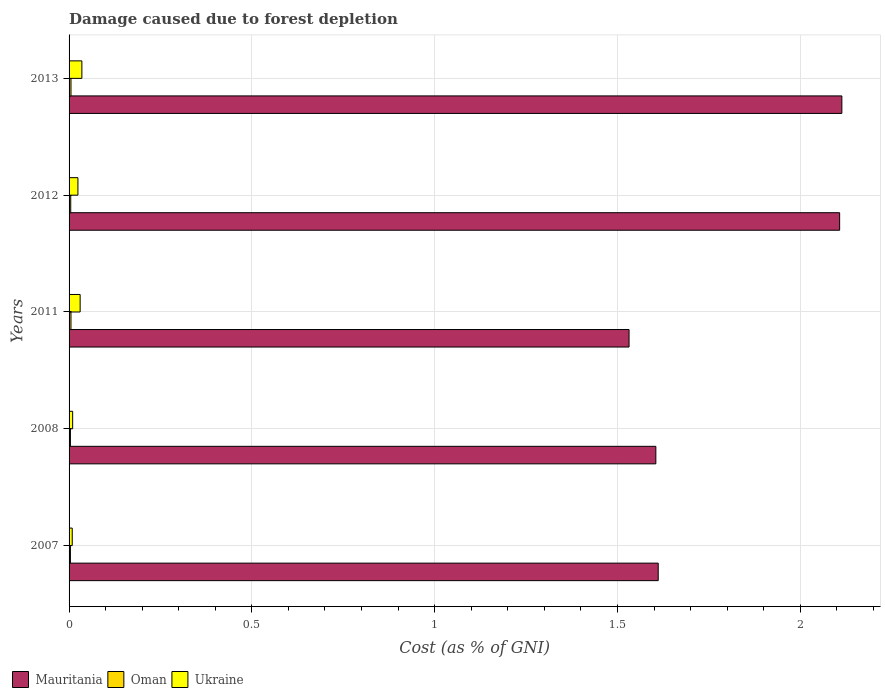Are the number of bars per tick equal to the number of legend labels?
Offer a very short reply. Yes. Are the number of bars on each tick of the Y-axis equal?
Provide a short and direct response. Yes. How many bars are there on the 3rd tick from the bottom?
Your answer should be compact. 3. What is the label of the 3rd group of bars from the top?
Offer a terse response. 2011. In how many cases, is the number of bars for a given year not equal to the number of legend labels?
Provide a succinct answer. 0. What is the cost of damage caused due to forest depletion in Ukraine in 2013?
Make the answer very short. 0.04. Across all years, what is the maximum cost of damage caused due to forest depletion in Ukraine?
Provide a short and direct response. 0.04. Across all years, what is the minimum cost of damage caused due to forest depletion in Mauritania?
Your answer should be compact. 1.53. In which year was the cost of damage caused due to forest depletion in Ukraine minimum?
Ensure brevity in your answer.  2007. What is the total cost of damage caused due to forest depletion in Mauritania in the graph?
Provide a succinct answer. 8.97. What is the difference between the cost of damage caused due to forest depletion in Oman in 2012 and that in 2013?
Make the answer very short. -0. What is the difference between the cost of damage caused due to forest depletion in Ukraine in 2008 and the cost of damage caused due to forest depletion in Mauritania in 2012?
Provide a short and direct response. -2.1. What is the average cost of damage caused due to forest depletion in Mauritania per year?
Your response must be concise. 1.79. In the year 2007, what is the difference between the cost of damage caused due to forest depletion in Mauritania and cost of damage caused due to forest depletion in Ukraine?
Your response must be concise. 1.6. In how many years, is the cost of damage caused due to forest depletion in Ukraine greater than 2 %?
Keep it short and to the point. 0. What is the ratio of the cost of damage caused due to forest depletion in Ukraine in 2007 to that in 2012?
Provide a succinct answer. 0.36. What is the difference between the highest and the second highest cost of damage caused due to forest depletion in Oman?
Provide a short and direct response. 2.9592775541019585e-5. What is the difference between the highest and the lowest cost of damage caused due to forest depletion in Mauritania?
Provide a short and direct response. 0.58. In how many years, is the cost of damage caused due to forest depletion in Ukraine greater than the average cost of damage caused due to forest depletion in Ukraine taken over all years?
Your response must be concise. 3. Is the sum of the cost of damage caused due to forest depletion in Ukraine in 2007 and 2008 greater than the maximum cost of damage caused due to forest depletion in Oman across all years?
Provide a succinct answer. Yes. What does the 2nd bar from the top in 2011 represents?
Keep it short and to the point. Oman. What does the 2nd bar from the bottom in 2011 represents?
Keep it short and to the point. Oman. Are all the bars in the graph horizontal?
Offer a very short reply. Yes. What is the difference between two consecutive major ticks on the X-axis?
Your answer should be compact. 0.5. Are the values on the major ticks of X-axis written in scientific E-notation?
Give a very brief answer. No. What is the title of the graph?
Make the answer very short. Damage caused due to forest depletion. Does "Israel" appear as one of the legend labels in the graph?
Keep it short and to the point. No. What is the label or title of the X-axis?
Provide a short and direct response. Cost (as % of GNI). What is the label or title of the Y-axis?
Provide a short and direct response. Years. What is the Cost (as % of GNI) in Mauritania in 2007?
Your answer should be compact. 1.61. What is the Cost (as % of GNI) of Oman in 2007?
Your response must be concise. 0. What is the Cost (as % of GNI) of Ukraine in 2007?
Give a very brief answer. 0.01. What is the Cost (as % of GNI) in Mauritania in 2008?
Give a very brief answer. 1.61. What is the Cost (as % of GNI) of Oman in 2008?
Keep it short and to the point. 0. What is the Cost (as % of GNI) of Ukraine in 2008?
Make the answer very short. 0.01. What is the Cost (as % of GNI) in Mauritania in 2011?
Your response must be concise. 1.53. What is the Cost (as % of GNI) of Oman in 2011?
Give a very brief answer. 0.01. What is the Cost (as % of GNI) of Ukraine in 2011?
Offer a very short reply. 0.03. What is the Cost (as % of GNI) of Mauritania in 2012?
Your response must be concise. 2.11. What is the Cost (as % of GNI) of Oman in 2012?
Your response must be concise. 0. What is the Cost (as % of GNI) in Ukraine in 2012?
Provide a succinct answer. 0.02. What is the Cost (as % of GNI) in Mauritania in 2013?
Your answer should be very brief. 2.11. What is the Cost (as % of GNI) in Oman in 2013?
Provide a short and direct response. 0.01. What is the Cost (as % of GNI) of Ukraine in 2013?
Make the answer very short. 0.04. Across all years, what is the maximum Cost (as % of GNI) in Mauritania?
Offer a terse response. 2.11. Across all years, what is the maximum Cost (as % of GNI) of Oman?
Make the answer very short. 0.01. Across all years, what is the maximum Cost (as % of GNI) of Ukraine?
Your answer should be compact. 0.04. Across all years, what is the minimum Cost (as % of GNI) of Mauritania?
Offer a very short reply. 1.53. Across all years, what is the minimum Cost (as % of GNI) in Oman?
Ensure brevity in your answer.  0. Across all years, what is the minimum Cost (as % of GNI) of Ukraine?
Make the answer very short. 0.01. What is the total Cost (as % of GNI) in Mauritania in the graph?
Your answer should be compact. 8.97. What is the total Cost (as % of GNI) of Oman in the graph?
Ensure brevity in your answer.  0.02. What is the total Cost (as % of GNI) of Ukraine in the graph?
Offer a very short reply. 0.11. What is the difference between the Cost (as % of GNI) of Mauritania in 2007 and that in 2008?
Provide a succinct answer. 0.01. What is the difference between the Cost (as % of GNI) in Ukraine in 2007 and that in 2008?
Your response must be concise. -0. What is the difference between the Cost (as % of GNI) of Mauritania in 2007 and that in 2011?
Ensure brevity in your answer.  0.08. What is the difference between the Cost (as % of GNI) in Oman in 2007 and that in 2011?
Make the answer very short. -0. What is the difference between the Cost (as % of GNI) in Ukraine in 2007 and that in 2011?
Offer a terse response. -0.02. What is the difference between the Cost (as % of GNI) in Mauritania in 2007 and that in 2012?
Ensure brevity in your answer.  -0.5. What is the difference between the Cost (as % of GNI) in Oman in 2007 and that in 2012?
Ensure brevity in your answer.  -0. What is the difference between the Cost (as % of GNI) in Ukraine in 2007 and that in 2012?
Ensure brevity in your answer.  -0.02. What is the difference between the Cost (as % of GNI) in Mauritania in 2007 and that in 2013?
Provide a short and direct response. -0.5. What is the difference between the Cost (as % of GNI) of Oman in 2007 and that in 2013?
Your answer should be compact. -0. What is the difference between the Cost (as % of GNI) in Ukraine in 2007 and that in 2013?
Make the answer very short. -0.03. What is the difference between the Cost (as % of GNI) in Mauritania in 2008 and that in 2011?
Your response must be concise. 0.07. What is the difference between the Cost (as % of GNI) of Oman in 2008 and that in 2011?
Make the answer very short. -0. What is the difference between the Cost (as % of GNI) of Ukraine in 2008 and that in 2011?
Offer a terse response. -0.02. What is the difference between the Cost (as % of GNI) in Mauritania in 2008 and that in 2012?
Provide a short and direct response. -0.5. What is the difference between the Cost (as % of GNI) of Oman in 2008 and that in 2012?
Ensure brevity in your answer.  -0. What is the difference between the Cost (as % of GNI) in Ukraine in 2008 and that in 2012?
Make the answer very short. -0.01. What is the difference between the Cost (as % of GNI) in Mauritania in 2008 and that in 2013?
Provide a short and direct response. -0.51. What is the difference between the Cost (as % of GNI) of Oman in 2008 and that in 2013?
Make the answer very short. -0. What is the difference between the Cost (as % of GNI) of Ukraine in 2008 and that in 2013?
Your answer should be compact. -0.03. What is the difference between the Cost (as % of GNI) in Mauritania in 2011 and that in 2012?
Provide a succinct answer. -0.58. What is the difference between the Cost (as % of GNI) of Oman in 2011 and that in 2012?
Make the answer very short. 0. What is the difference between the Cost (as % of GNI) of Ukraine in 2011 and that in 2012?
Your answer should be compact. 0.01. What is the difference between the Cost (as % of GNI) of Mauritania in 2011 and that in 2013?
Make the answer very short. -0.58. What is the difference between the Cost (as % of GNI) of Ukraine in 2011 and that in 2013?
Make the answer very short. -0. What is the difference between the Cost (as % of GNI) in Mauritania in 2012 and that in 2013?
Provide a succinct answer. -0.01. What is the difference between the Cost (as % of GNI) of Oman in 2012 and that in 2013?
Provide a short and direct response. -0. What is the difference between the Cost (as % of GNI) in Ukraine in 2012 and that in 2013?
Offer a terse response. -0.01. What is the difference between the Cost (as % of GNI) in Mauritania in 2007 and the Cost (as % of GNI) in Oman in 2008?
Provide a succinct answer. 1.61. What is the difference between the Cost (as % of GNI) in Mauritania in 2007 and the Cost (as % of GNI) in Ukraine in 2008?
Your answer should be compact. 1.6. What is the difference between the Cost (as % of GNI) in Oman in 2007 and the Cost (as % of GNI) in Ukraine in 2008?
Offer a very short reply. -0.01. What is the difference between the Cost (as % of GNI) of Mauritania in 2007 and the Cost (as % of GNI) of Oman in 2011?
Make the answer very short. 1.61. What is the difference between the Cost (as % of GNI) of Mauritania in 2007 and the Cost (as % of GNI) of Ukraine in 2011?
Your answer should be very brief. 1.58. What is the difference between the Cost (as % of GNI) of Oman in 2007 and the Cost (as % of GNI) of Ukraine in 2011?
Provide a short and direct response. -0.03. What is the difference between the Cost (as % of GNI) in Mauritania in 2007 and the Cost (as % of GNI) in Oman in 2012?
Give a very brief answer. 1.61. What is the difference between the Cost (as % of GNI) in Mauritania in 2007 and the Cost (as % of GNI) in Ukraine in 2012?
Give a very brief answer. 1.59. What is the difference between the Cost (as % of GNI) of Oman in 2007 and the Cost (as % of GNI) of Ukraine in 2012?
Make the answer very short. -0.02. What is the difference between the Cost (as % of GNI) of Mauritania in 2007 and the Cost (as % of GNI) of Oman in 2013?
Offer a very short reply. 1.61. What is the difference between the Cost (as % of GNI) in Mauritania in 2007 and the Cost (as % of GNI) in Ukraine in 2013?
Make the answer very short. 1.58. What is the difference between the Cost (as % of GNI) in Oman in 2007 and the Cost (as % of GNI) in Ukraine in 2013?
Your answer should be very brief. -0.03. What is the difference between the Cost (as % of GNI) in Mauritania in 2008 and the Cost (as % of GNI) in Oman in 2011?
Ensure brevity in your answer.  1.6. What is the difference between the Cost (as % of GNI) of Mauritania in 2008 and the Cost (as % of GNI) of Ukraine in 2011?
Offer a very short reply. 1.57. What is the difference between the Cost (as % of GNI) of Oman in 2008 and the Cost (as % of GNI) of Ukraine in 2011?
Provide a succinct answer. -0.03. What is the difference between the Cost (as % of GNI) in Mauritania in 2008 and the Cost (as % of GNI) in Oman in 2012?
Your response must be concise. 1.6. What is the difference between the Cost (as % of GNI) in Mauritania in 2008 and the Cost (as % of GNI) in Ukraine in 2012?
Ensure brevity in your answer.  1.58. What is the difference between the Cost (as % of GNI) of Oman in 2008 and the Cost (as % of GNI) of Ukraine in 2012?
Keep it short and to the point. -0.02. What is the difference between the Cost (as % of GNI) in Mauritania in 2008 and the Cost (as % of GNI) in Oman in 2013?
Offer a terse response. 1.6. What is the difference between the Cost (as % of GNI) in Mauritania in 2008 and the Cost (as % of GNI) in Ukraine in 2013?
Provide a succinct answer. 1.57. What is the difference between the Cost (as % of GNI) in Oman in 2008 and the Cost (as % of GNI) in Ukraine in 2013?
Make the answer very short. -0.03. What is the difference between the Cost (as % of GNI) in Mauritania in 2011 and the Cost (as % of GNI) in Oman in 2012?
Your answer should be very brief. 1.53. What is the difference between the Cost (as % of GNI) of Mauritania in 2011 and the Cost (as % of GNI) of Ukraine in 2012?
Your response must be concise. 1.51. What is the difference between the Cost (as % of GNI) in Oman in 2011 and the Cost (as % of GNI) in Ukraine in 2012?
Provide a short and direct response. -0.02. What is the difference between the Cost (as % of GNI) of Mauritania in 2011 and the Cost (as % of GNI) of Oman in 2013?
Offer a terse response. 1.53. What is the difference between the Cost (as % of GNI) of Mauritania in 2011 and the Cost (as % of GNI) of Ukraine in 2013?
Your response must be concise. 1.5. What is the difference between the Cost (as % of GNI) of Oman in 2011 and the Cost (as % of GNI) of Ukraine in 2013?
Make the answer very short. -0.03. What is the difference between the Cost (as % of GNI) of Mauritania in 2012 and the Cost (as % of GNI) of Oman in 2013?
Provide a succinct answer. 2.1. What is the difference between the Cost (as % of GNI) of Mauritania in 2012 and the Cost (as % of GNI) of Ukraine in 2013?
Keep it short and to the point. 2.07. What is the difference between the Cost (as % of GNI) in Oman in 2012 and the Cost (as % of GNI) in Ukraine in 2013?
Offer a terse response. -0.03. What is the average Cost (as % of GNI) in Mauritania per year?
Provide a succinct answer. 1.79. What is the average Cost (as % of GNI) of Oman per year?
Ensure brevity in your answer.  0. What is the average Cost (as % of GNI) of Ukraine per year?
Provide a succinct answer. 0.02. In the year 2007, what is the difference between the Cost (as % of GNI) of Mauritania and Cost (as % of GNI) of Oman?
Provide a succinct answer. 1.61. In the year 2007, what is the difference between the Cost (as % of GNI) of Mauritania and Cost (as % of GNI) of Ukraine?
Make the answer very short. 1.6. In the year 2007, what is the difference between the Cost (as % of GNI) of Oman and Cost (as % of GNI) of Ukraine?
Offer a very short reply. -0.01. In the year 2008, what is the difference between the Cost (as % of GNI) in Mauritania and Cost (as % of GNI) in Oman?
Give a very brief answer. 1.6. In the year 2008, what is the difference between the Cost (as % of GNI) of Mauritania and Cost (as % of GNI) of Ukraine?
Offer a very short reply. 1.6. In the year 2008, what is the difference between the Cost (as % of GNI) of Oman and Cost (as % of GNI) of Ukraine?
Offer a very short reply. -0.01. In the year 2011, what is the difference between the Cost (as % of GNI) of Mauritania and Cost (as % of GNI) of Oman?
Offer a very short reply. 1.53. In the year 2011, what is the difference between the Cost (as % of GNI) of Mauritania and Cost (as % of GNI) of Ukraine?
Your answer should be very brief. 1.5. In the year 2011, what is the difference between the Cost (as % of GNI) in Oman and Cost (as % of GNI) in Ukraine?
Ensure brevity in your answer.  -0.03. In the year 2012, what is the difference between the Cost (as % of GNI) in Mauritania and Cost (as % of GNI) in Oman?
Ensure brevity in your answer.  2.1. In the year 2012, what is the difference between the Cost (as % of GNI) in Mauritania and Cost (as % of GNI) in Ukraine?
Provide a short and direct response. 2.08. In the year 2012, what is the difference between the Cost (as % of GNI) in Oman and Cost (as % of GNI) in Ukraine?
Your answer should be very brief. -0.02. In the year 2013, what is the difference between the Cost (as % of GNI) in Mauritania and Cost (as % of GNI) in Oman?
Offer a terse response. 2.11. In the year 2013, what is the difference between the Cost (as % of GNI) in Mauritania and Cost (as % of GNI) in Ukraine?
Offer a very short reply. 2.08. In the year 2013, what is the difference between the Cost (as % of GNI) of Oman and Cost (as % of GNI) of Ukraine?
Offer a terse response. -0.03. What is the ratio of the Cost (as % of GNI) of Ukraine in 2007 to that in 2008?
Give a very brief answer. 0.88. What is the ratio of the Cost (as % of GNI) of Mauritania in 2007 to that in 2011?
Provide a short and direct response. 1.05. What is the ratio of the Cost (as % of GNI) of Oman in 2007 to that in 2011?
Make the answer very short. 0.71. What is the ratio of the Cost (as % of GNI) in Ukraine in 2007 to that in 2011?
Make the answer very short. 0.29. What is the ratio of the Cost (as % of GNI) in Mauritania in 2007 to that in 2012?
Give a very brief answer. 0.76. What is the ratio of the Cost (as % of GNI) in Oman in 2007 to that in 2012?
Your answer should be very brief. 0.81. What is the ratio of the Cost (as % of GNI) of Ukraine in 2007 to that in 2012?
Your response must be concise. 0.36. What is the ratio of the Cost (as % of GNI) of Mauritania in 2007 to that in 2013?
Make the answer very short. 0.76. What is the ratio of the Cost (as % of GNI) of Oman in 2007 to that in 2013?
Provide a succinct answer. 0.71. What is the ratio of the Cost (as % of GNI) in Ukraine in 2007 to that in 2013?
Provide a short and direct response. 0.25. What is the ratio of the Cost (as % of GNI) in Mauritania in 2008 to that in 2011?
Keep it short and to the point. 1.05. What is the ratio of the Cost (as % of GNI) of Oman in 2008 to that in 2011?
Your response must be concise. 0.71. What is the ratio of the Cost (as % of GNI) in Ukraine in 2008 to that in 2011?
Provide a succinct answer. 0.32. What is the ratio of the Cost (as % of GNI) of Mauritania in 2008 to that in 2012?
Keep it short and to the point. 0.76. What is the ratio of the Cost (as % of GNI) in Oman in 2008 to that in 2012?
Give a very brief answer. 0.81. What is the ratio of the Cost (as % of GNI) of Ukraine in 2008 to that in 2012?
Give a very brief answer. 0.41. What is the ratio of the Cost (as % of GNI) of Mauritania in 2008 to that in 2013?
Give a very brief answer. 0.76. What is the ratio of the Cost (as % of GNI) in Oman in 2008 to that in 2013?
Keep it short and to the point. 0.71. What is the ratio of the Cost (as % of GNI) of Ukraine in 2008 to that in 2013?
Offer a very short reply. 0.28. What is the ratio of the Cost (as % of GNI) of Mauritania in 2011 to that in 2012?
Offer a very short reply. 0.73. What is the ratio of the Cost (as % of GNI) in Oman in 2011 to that in 2012?
Your answer should be compact. 1.14. What is the ratio of the Cost (as % of GNI) in Ukraine in 2011 to that in 2012?
Make the answer very short. 1.25. What is the ratio of the Cost (as % of GNI) in Mauritania in 2011 to that in 2013?
Provide a succinct answer. 0.72. What is the ratio of the Cost (as % of GNI) in Oman in 2011 to that in 2013?
Give a very brief answer. 0.99. What is the ratio of the Cost (as % of GNI) of Ukraine in 2011 to that in 2013?
Ensure brevity in your answer.  0.86. What is the ratio of the Cost (as % of GNI) of Oman in 2012 to that in 2013?
Your response must be concise. 0.87. What is the ratio of the Cost (as % of GNI) of Ukraine in 2012 to that in 2013?
Offer a terse response. 0.69. What is the difference between the highest and the second highest Cost (as % of GNI) in Mauritania?
Your answer should be very brief. 0.01. What is the difference between the highest and the second highest Cost (as % of GNI) in Ukraine?
Offer a very short reply. 0. What is the difference between the highest and the lowest Cost (as % of GNI) in Mauritania?
Your response must be concise. 0.58. What is the difference between the highest and the lowest Cost (as % of GNI) in Oman?
Provide a succinct answer. 0. What is the difference between the highest and the lowest Cost (as % of GNI) in Ukraine?
Offer a terse response. 0.03. 